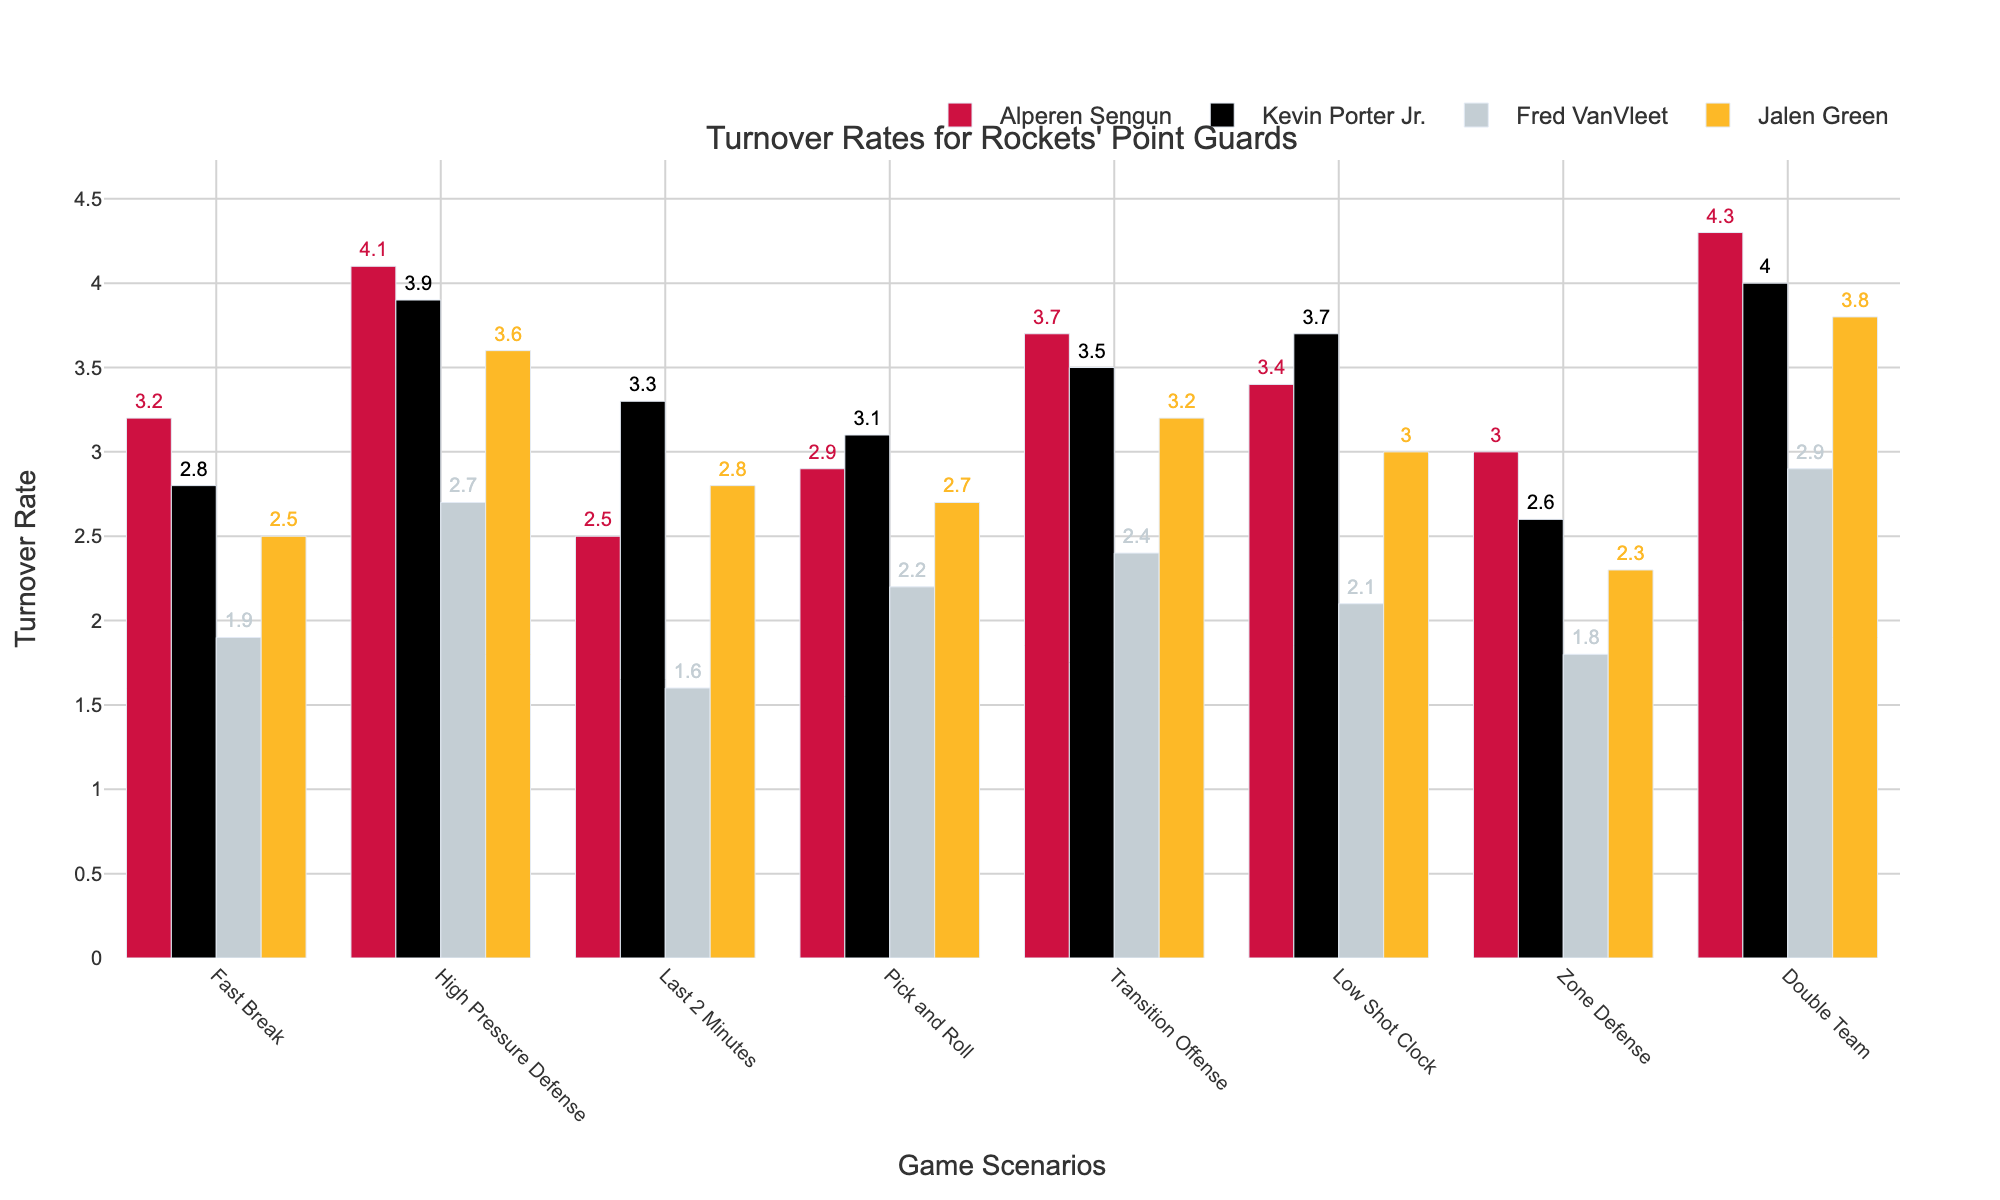Which point guard has the highest turnover rate under High Pressure Defense? Look at the bar heights under the scenario "High Pressure Defense", identify the tallest bar. Alperen Sengun has the highest bar.
Answer: Alperen Sengun Which player has the lowest turnover rate during Last 2 Minutes? Compare the bars for each player under the "Last 2 Minutes" scenario. The shortest bar represents the lowest turnover rate. Fred VanVleet has the shortest bar.
Answer: Fred VanVleet How does Jalen Green's turnover rate in Fast Break compare to his rate in Transition Offense? For Jalen Green, compare his bar heights under "Fast Break" and "Transition Offense". The bar for "Transition Offense" is slightly lower than the bar for "Fast Break".
Answer: Lower in Transition Offense Which scenario shows Kevin Porter Jr. with the highest turnover rate? Look for the highest bar among the scenarios for Kevin Porter Jr. The highest bar is in the "Double Team" scenario.
Answer: Double Team What is the sum of turnover rates for Fred VanVleet across all scenarios? Add the heights of Fred VanVleet’s bars across all scenarios: 1.9 + 2.7 + 1.6 + 2.2 + 2.4 + 2.1 + 1.8 + 2.9 = 18.
Answer: 18 Who has the least consistent turnover rate, based on the variability of their bars? Assess the fluctuation in bar heights for each player. Alperen Sengun’s bars show significant variability.
Answer: Alperen Sengun By how much does Alperen Sengun's turnover rate in Double Team scenarios exceed that of Fred VanVleet? Subtract Fred VanVleet’s double team turnover rate from Alperen Sengun’s: 4.3 - 2.9 = 1.4.
Answer: 1.4 Is there any scenario where all players have a turnover rate above 2? Check each scenario to ensure all bar heights are greater than 2. In the "High Pressure Defense" and "Double Team" scenarios, all players have rates above 2.
Answer: Yes, two scenarios What's the average turnover rate for Jalen Green in the scenarios shown? Add Jalen Green’s turnover rates and divide by the number of scenarios: (2.5 + 3.6 + 2.8 + 2.7 + 3.2 + 3.0 + 2.3 + 3.8) / 8 = 3.025.
Answer: 3.025 Compare Alperen Sengun and Kevin Porter Jr.’s turnover rates in Low Shot Clock scenarios. Who has a higher rate and by how much? Subtract Kevin Porter Jr.'s turnover rate from Alperen Sengun’s: 3.4 - 3.7 = -0.3. Kevin Porter Jr. has a higher rate by 0.3.
Answer: Kevin Porter Jr. by 0.3 